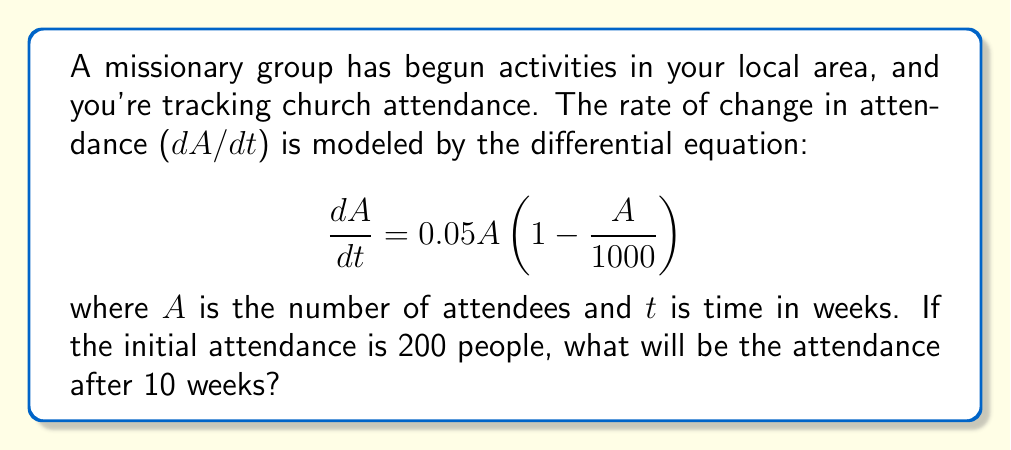Show me your answer to this math problem. To solve this problem, we need to use the logistic growth model, which is represented by the given differential equation. Let's approach this step-by-step:

1) The given equation is a separable differential equation. We can solve it using the following steps:

2) Separate the variables:
   $$ \frac{dA}{A(1 - \frac{A}{1000})} = 0.05dt $$

3) Integrate both sides:
   $$ \int \frac{dA}{A(1 - \frac{A}{1000})} = \int 0.05dt $$

4) The left side can be integrated using partial fractions. After integration, we get:
   $$ -\ln|1 - \frac{A}{1000}| - \ln|A| = 0.05t + C $$

5) Simplify and solve for A:
   $$ A = \frac{1000}{1 + Ce^{-0.05t}} $$

6) Use the initial condition A(0) = 200 to find C:
   $$ 200 = \frac{1000}{1 + C} $$
   $$ C = 4 $$

7) Therefore, the solution is:
   $$ A = \frac{1000}{1 + 4e^{-0.05t}} $$

8) To find A(10), substitute t = 10:
   $$ A(10) = \frac{1000}{1 + 4e^{-0.5}} $$

9) Calculate the result:
   $$ A(10) \approx 378.78 $$
Answer: The church attendance after 10 weeks will be approximately 379 people (rounded to the nearest integer). 